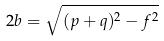Convert formula to latex. <formula><loc_0><loc_0><loc_500><loc_500>2 b = \sqrt { ( p + q ) ^ { 2 } - f ^ { 2 } }</formula> 